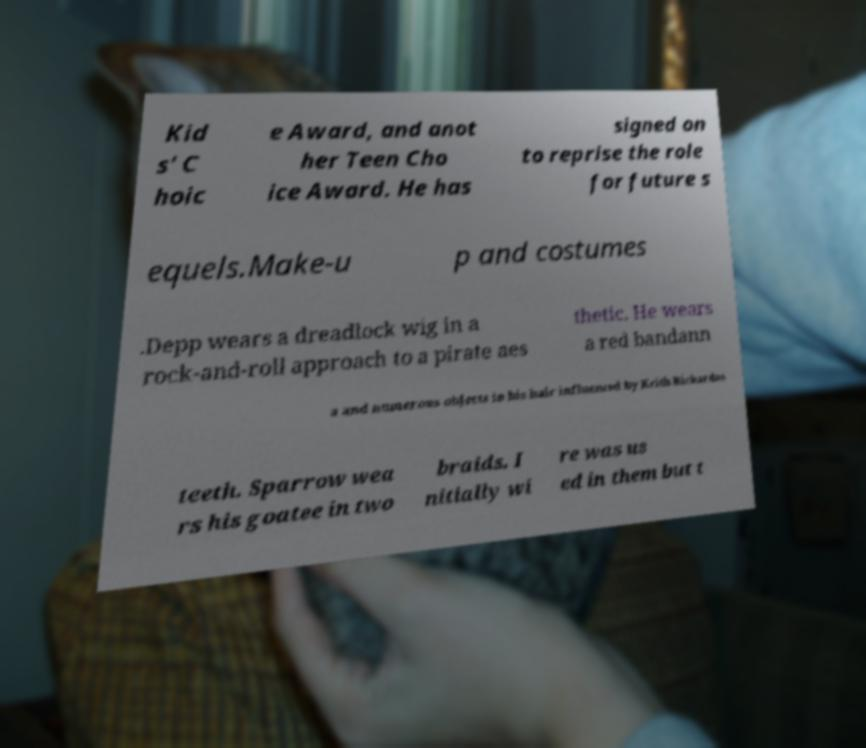Can you accurately transcribe the text from the provided image for me? Kid s' C hoic e Award, and anot her Teen Cho ice Award. He has signed on to reprise the role for future s equels.Make-u p and costumes .Depp wears a dreadlock wig in a rock-and-roll approach to a pirate aes thetic. He wears a red bandann a and numerous objects in his hair influenced by Keith Richardss teeth. Sparrow wea rs his goatee in two braids. I nitially wi re was us ed in them but t 